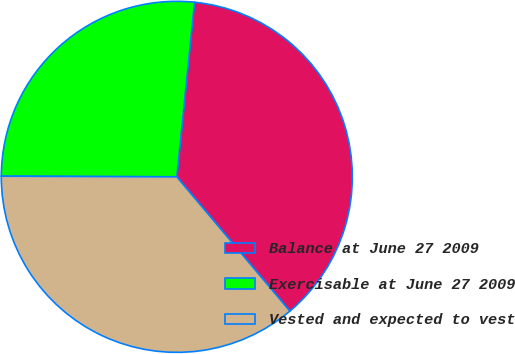<chart> <loc_0><loc_0><loc_500><loc_500><pie_chart><fcel>Balance at June 27 2009<fcel>Exercisable at June 27 2009<fcel>Vested and expected to vest<nl><fcel>37.25%<fcel>26.55%<fcel>36.2%<nl></chart> 